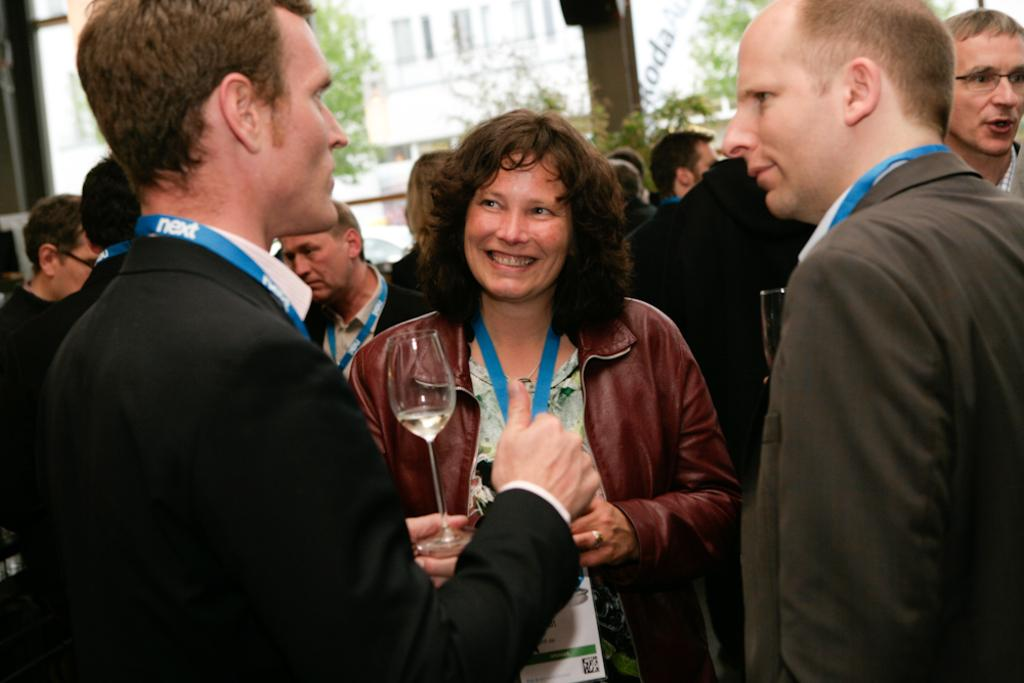How many people are visible in the image? There are three people standing in the image. What are the people holding in their hands? The people are holding wine glasses. What are the people doing in the image? The people are discussing something. Can you describe the background of the image? There are more people, trees, and a building in the background of the image. What type of button is being used to control the snow in the image? There is no button or snow present in the image. Can you tell me the name of the person's partner in the image? There is no mention of a partner or relationship between the people in the image. 